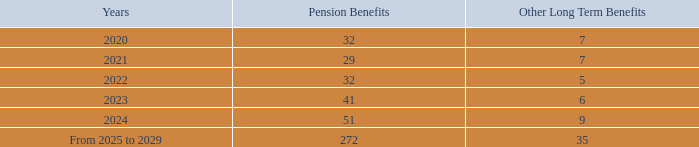The Company’s estimated future benefit payments as of December 31, 2019 are as follows:
The Company has certain defined contribution plans, which accrue benefits for employees on a pro-rata basis during their employment period based on their individual salaries. The Company’s accrued benefits related to defined contribution pension plans of $20 million as of December 31, 2019 and $18 million as of December 31, 2018. The annual cost of these plans amounted to approximately $86 million in 2019, $84 million in 2018 and $77 million in 2017.
What was the annual cost of contribution pension plans in 2019? $86 million. What was the annual cost of contribution pension plans in 2018? $84 million. What was the annual cost of contribution pension plans in 2017? $77 million. What is the average benefit payments for 2020 to 2021?
Answer scale should be: million. (32+29) / 2
Answer: 30.5. What is the average benefit payments for 2021 to 2022?
Answer scale should be: million. (29+32) / 2
Answer: 30.5. What is the average benefit payments for 2022 to 2023?
Answer scale should be: million. (32+41) / 2
Answer: 36.5. 